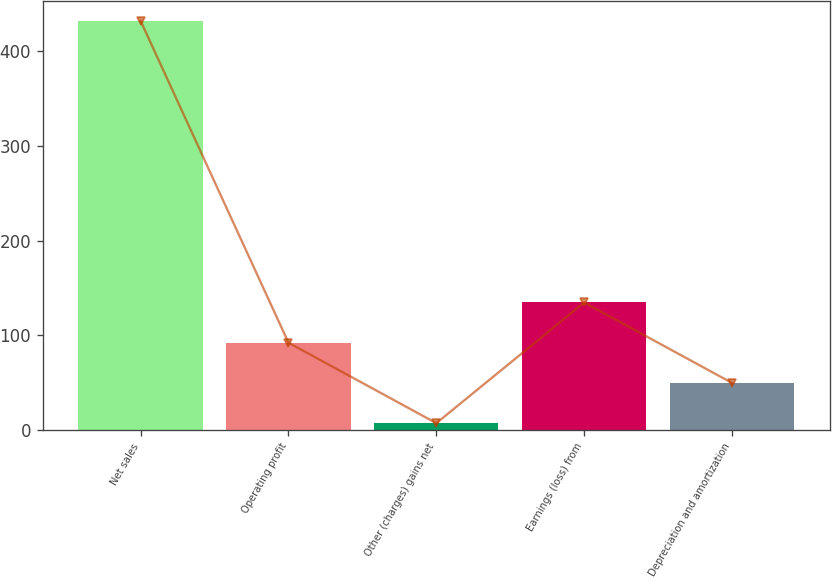Convert chart. <chart><loc_0><loc_0><loc_500><loc_500><bar_chart><fcel>Net sales<fcel>Operating profit<fcel>Other (charges) gains net<fcel>Earnings (loss) from<fcel>Depreciation and amortization<nl><fcel>432<fcel>92<fcel>7<fcel>134.5<fcel>49.5<nl></chart> 